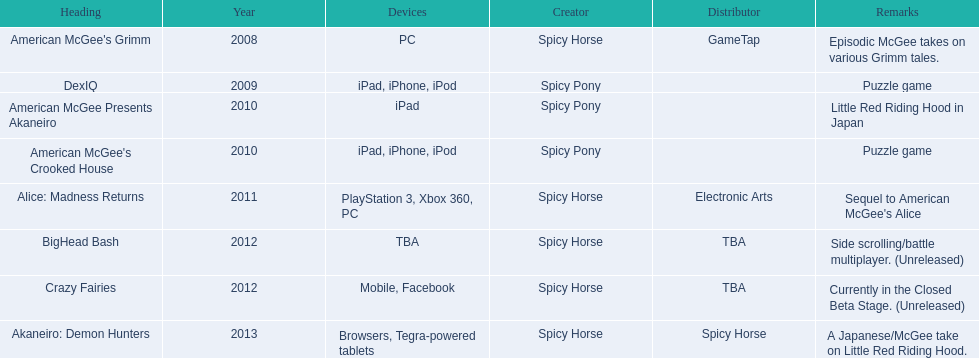What are all the titles? American McGee's Grimm, DexIQ, American McGee Presents Akaneiro, American McGee's Crooked House, Alice: Madness Returns, BigHead Bash, Crazy Fairies, Akaneiro: Demon Hunters. What platforms were they available on? PC, iPad, iPhone, iPod, iPad, iPad, iPhone, iPod, PlayStation 3, Xbox 360, PC, TBA, Mobile, Facebook, Browsers, Tegra-powered tablets. And which were available only on the ipad? American McGee Presents Akaneiro. 